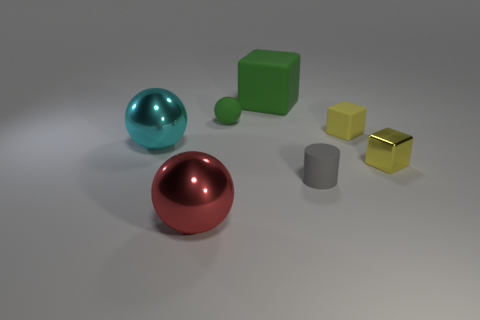Could you infer the texture of these objects? The objects appear to have a variety of textures. The spheres and the cylinder seem to have a shiny, smooth surface suggesting a reflective material, while the cubes look matte, indicating a more diffuse surface texture. Do the objects convey any particular theme or concept? The objects appear to be a collection of geometric shapes typically used in 3D modeling and rendering tests. They could represent concepts such as diversity, variety, and contrast in shapes and colors. 